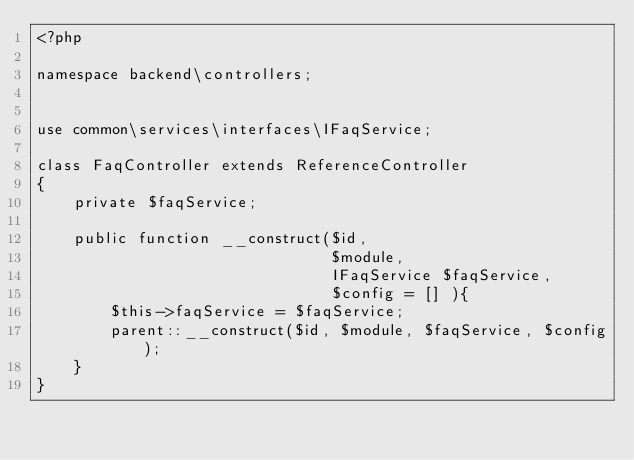Convert code to text. <code><loc_0><loc_0><loc_500><loc_500><_PHP_><?php

namespace backend\controllers;


use common\services\interfaces\IFaqService;

class FaqController extends ReferenceController
{
    private $faqService;

    public function __construct($id,
                                $module,
                                IFaqService $faqService,
                                $config = [] ){
        $this->faqService = $faqService;
        parent::__construct($id, $module, $faqService, $config);
    }
}</code> 